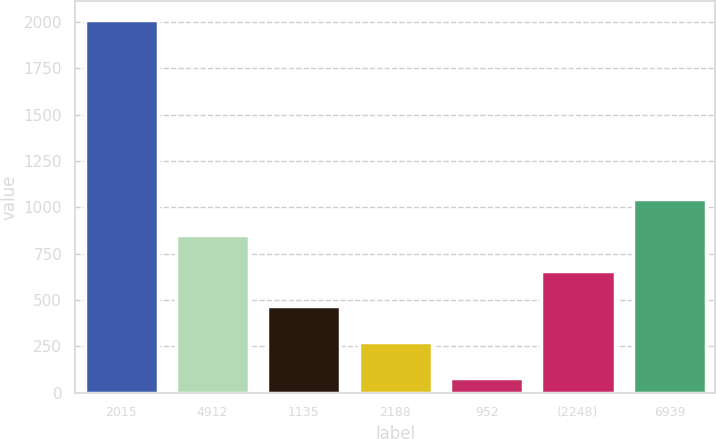Convert chart. <chart><loc_0><loc_0><loc_500><loc_500><bar_chart><fcel>2015<fcel>4912<fcel>1135<fcel>2188<fcel>952<fcel>(2248)<fcel>6939<nl><fcel>2013<fcel>852.78<fcel>466.04<fcel>272.67<fcel>79.3<fcel>659.41<fcel>1046.15<nl></chart> 